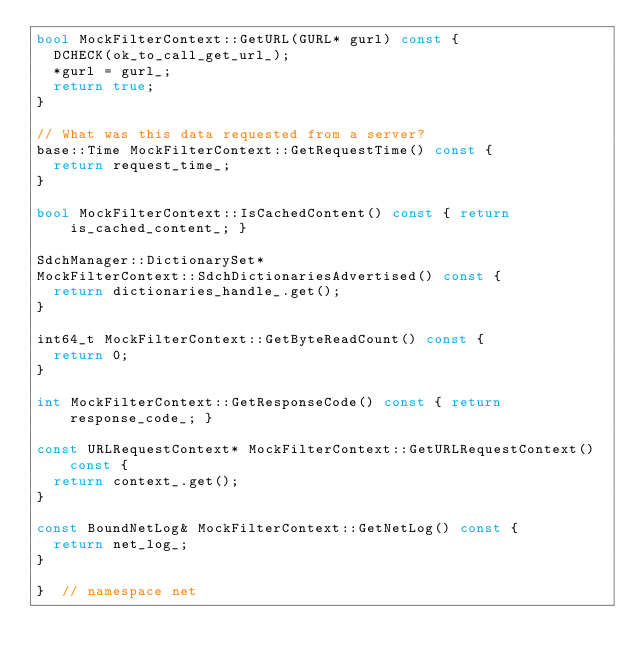<code> <loc_0><loc_0><loc_500><loc_500><_C++_>bool MockFilterContext::GetURL(GURL* gurl) const {
  DCHECK(ok_to_call_get_url_);
  *gurl = gurl_;
  return true;
}

// What was this data requested from a server?
base::Time MockFilterContext::GetRequestTime() const {
  return request_time_;
}

bool MockFilterContext::IsCachedContent() const { return is_cached_content_; }

SdchManager::DictionarySet*
MockFilterContext::SdchDictionariesAdvertised() const {
  return dictionaries_handle_.get();
}

int64_t MockFilterContext::GetByteReadCount() const {
  return 0;
}

int MockFilterContext::GetResponseCode() const { return response_code_; }

const URLRequestContext* MockFilterContext::GetURLRequestContext() const {
  return context_.get();
}

const BoundNetLog& MockFilterContext::GetNetLog() const {
  return net_log_;
}

}  // namespace net
</code> 